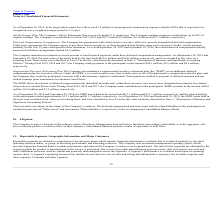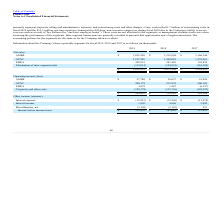According to Plexus's financial document, What was the net sales from AMER in 2017? According to the financial document, 1,166,346 (in thousands). The relevant text states: "AMER $ 1,429,308 $ 1,218,944 $ 1,166,346..." Also, What was the total net sales in 2019? According to the financial document, 3,164,434 (in thousands). The relevant text states: "$ 3,164,434 $ 2,873,508 $ 2,528,052..." Also, Which years does the table provide information for its reportable segments? The document contains multiple relevant values: 2019, 2018, 2017. From the document: "2019 2018 2017 2019 2018 2017 2019 2018 2017..." Also, How many years did the net sales from EMEA exceed $300,000 thousand? Based on the analysis, there are 1 instances. The counting process: 2019. Also, can you calculate: What was the change in the net sales from APAC between 2017 and 2018? Based on the calculation: 1,498,010-1,279,261, the result is 218749 (in thousands). This is based on the information: "APAC 1,557,205 1,498,010 1,279,261 APAC 1,557,205 1,498,010 1,279,261..." The key data points involved are: 1,279,261, 1,498,010. Also, can you calculate: What was the percentage change in the total net sales between 2018 and 2019? To answer this question, I need to perform calculations using the financial data. The calculation is: (3,164,434-2,873,508)/2,873,508, which equals 10.12 (percentage). This is based on the information: "$ 3,164,434 $ 2,873,508 $ 2,528,052 $ 3,164,434 $ 2,873,508 $ 2,528,052..." The key data points involved are: 2,873,508, 3,164,434. 